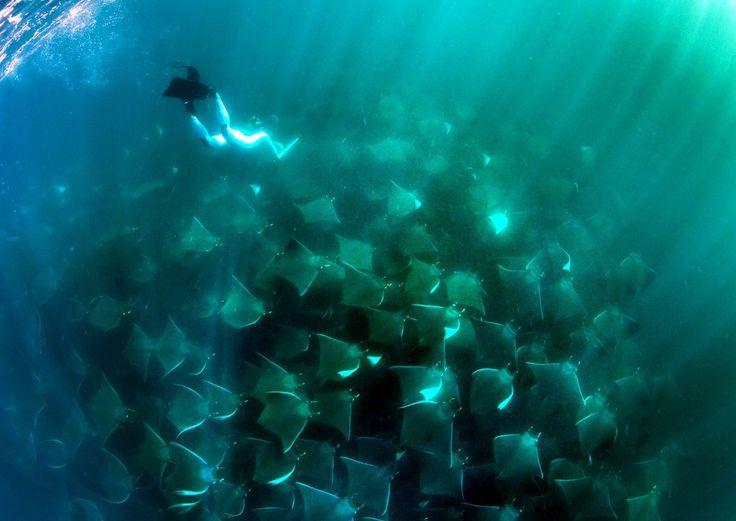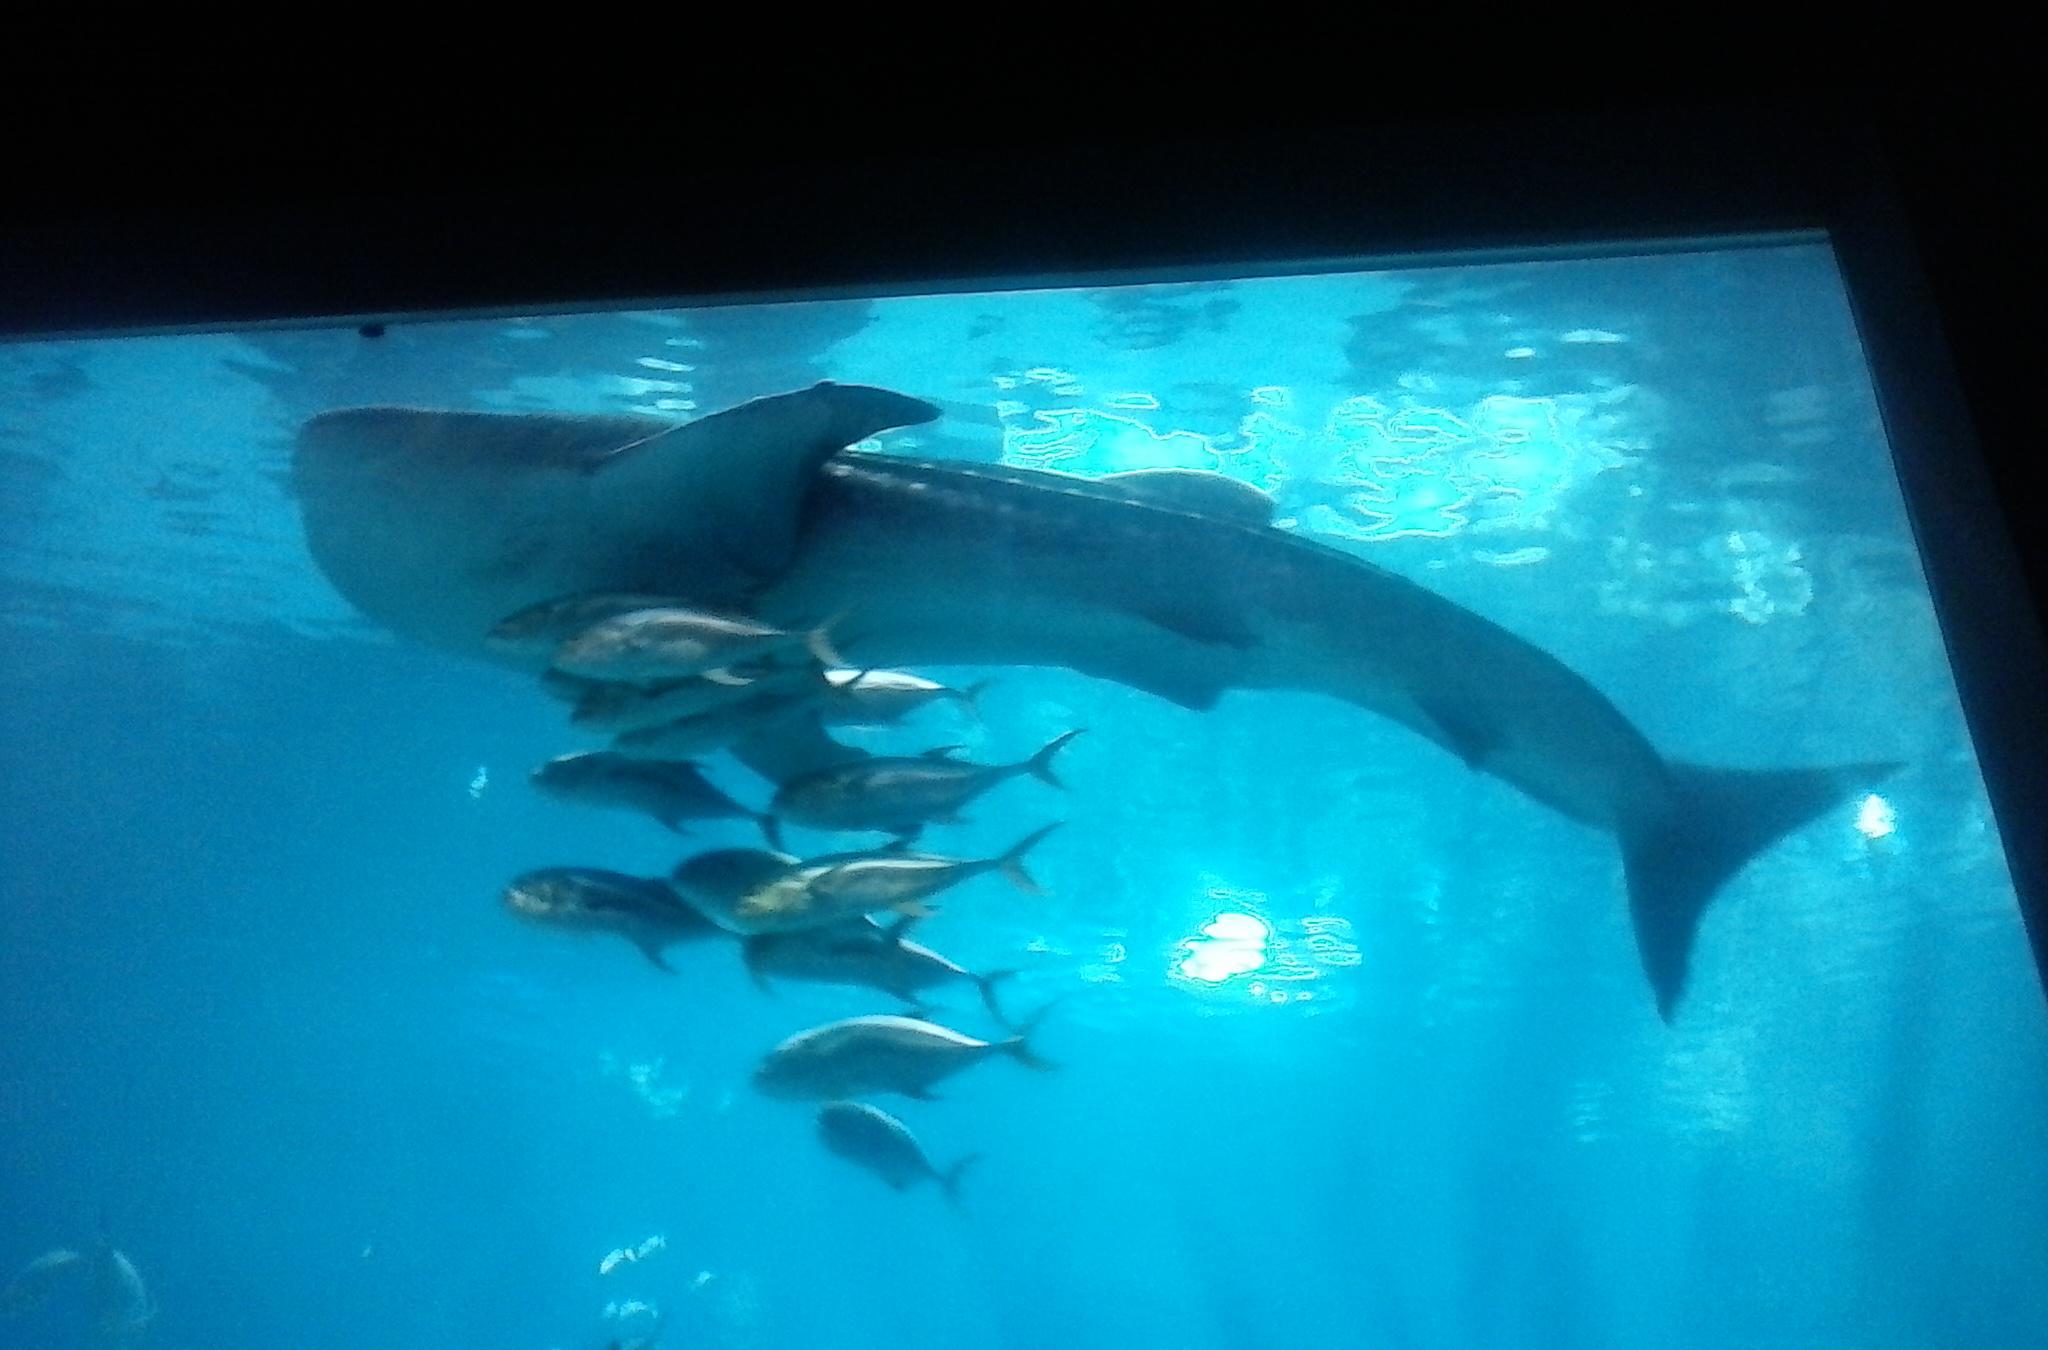The first image is the image on the left, the second image is the image on the right. Examine the images to the left and right. Is the description "An image contains no more than three stingray in the foreground." accurate? Answer yes or no. No. The first image is the image on the left, the second image is the image on the right. Analyze the images presented: Is the assertion "One stingray is on the ocean floor." valid? Answer yes or no. No. 